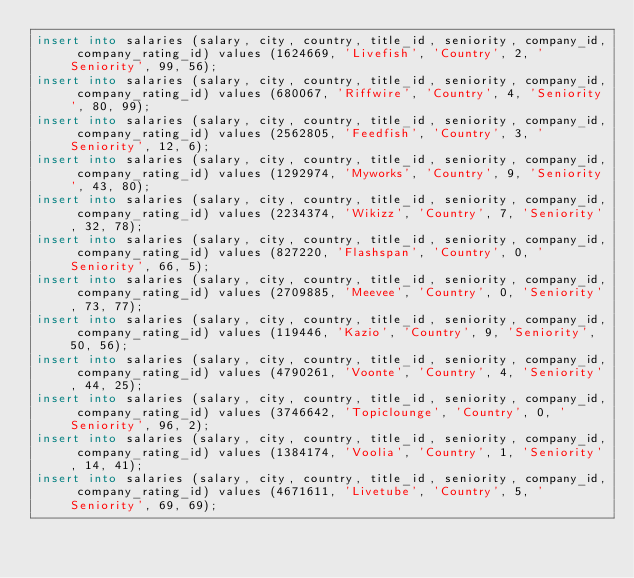<code> <loc_0><loc_0><loc_500><loc_500><_SQL_>insert into salaries (salary, city, country, title_id, seniority, company_id, company_rating_id) values (1624669, 'Livefish', 'Country', 2, 'Seniority', 99, 56);
insert into salaries (salary, city, country, title_id, seniority, company_id, company_rating_id) values (680067, 'Riffwire', 'Country', 4, 'Seniority', 80, 99);
insert into salaries (salary, city, country, title_id, seniority, company_id, company_rating_id) values (2562805, 'Feedfish', 'Country', 3, 'Seniority', 12, 6);
insert into salaries (salary, city, country, title_id, seniority, company_id, company_rating_id) values (1292974, 'Myworks', 'Country', 9, 'Seniority', 43, 80);
insert into salaries (salary, city, country, title_id, seniority, company_id, company_rating_id) values (2234374, 'Wikizz', 'Country', 7, 'Seniority', 32, 78);
insert into salaries (salary, city, country, title_id, seniority, company_id, company_rating_id) values (827220, 'Flashspan', 'Country', 0, 'Seniority', 66, 5);
insert into salaries (salary, city, country, title_id, seniority, company_id, company_rating_id) values (2709885, 'Meevee', 'Country', 0, 'Seniority', 73, 77);
insert into salaries (salary, city, country, title_id, seniority, company_id, company_rating_id) values (119446, 'Kazio', 'Country', 9, 'Seniority', 50, 56);
insert into salaries (salary, city, country, title_id, seniority, company_id, company_rating_id) values (4790261, 'Voonte', 'Country', 4, 'Seniority', 44, 25);
insert into salaries (salary, city, country, title_id, seniority, company_id, company_rating_id) values (3746642, 'Topiclounge', 'Country', 0, 'Seniority', 96, 2);
insert into salaries (salary, city, country, title_id, seniority, company_id, company_rating_id) values (1384174, 'Voolia', 'Country', 1, 'Seniority', 14, 41);
insert into salaries (salary, city, country, title_id, seniority, company_id, company_rating_id) values (4671611, 'Livetube', 'Country', 5, 'Seniority', 69, 69);</code> 